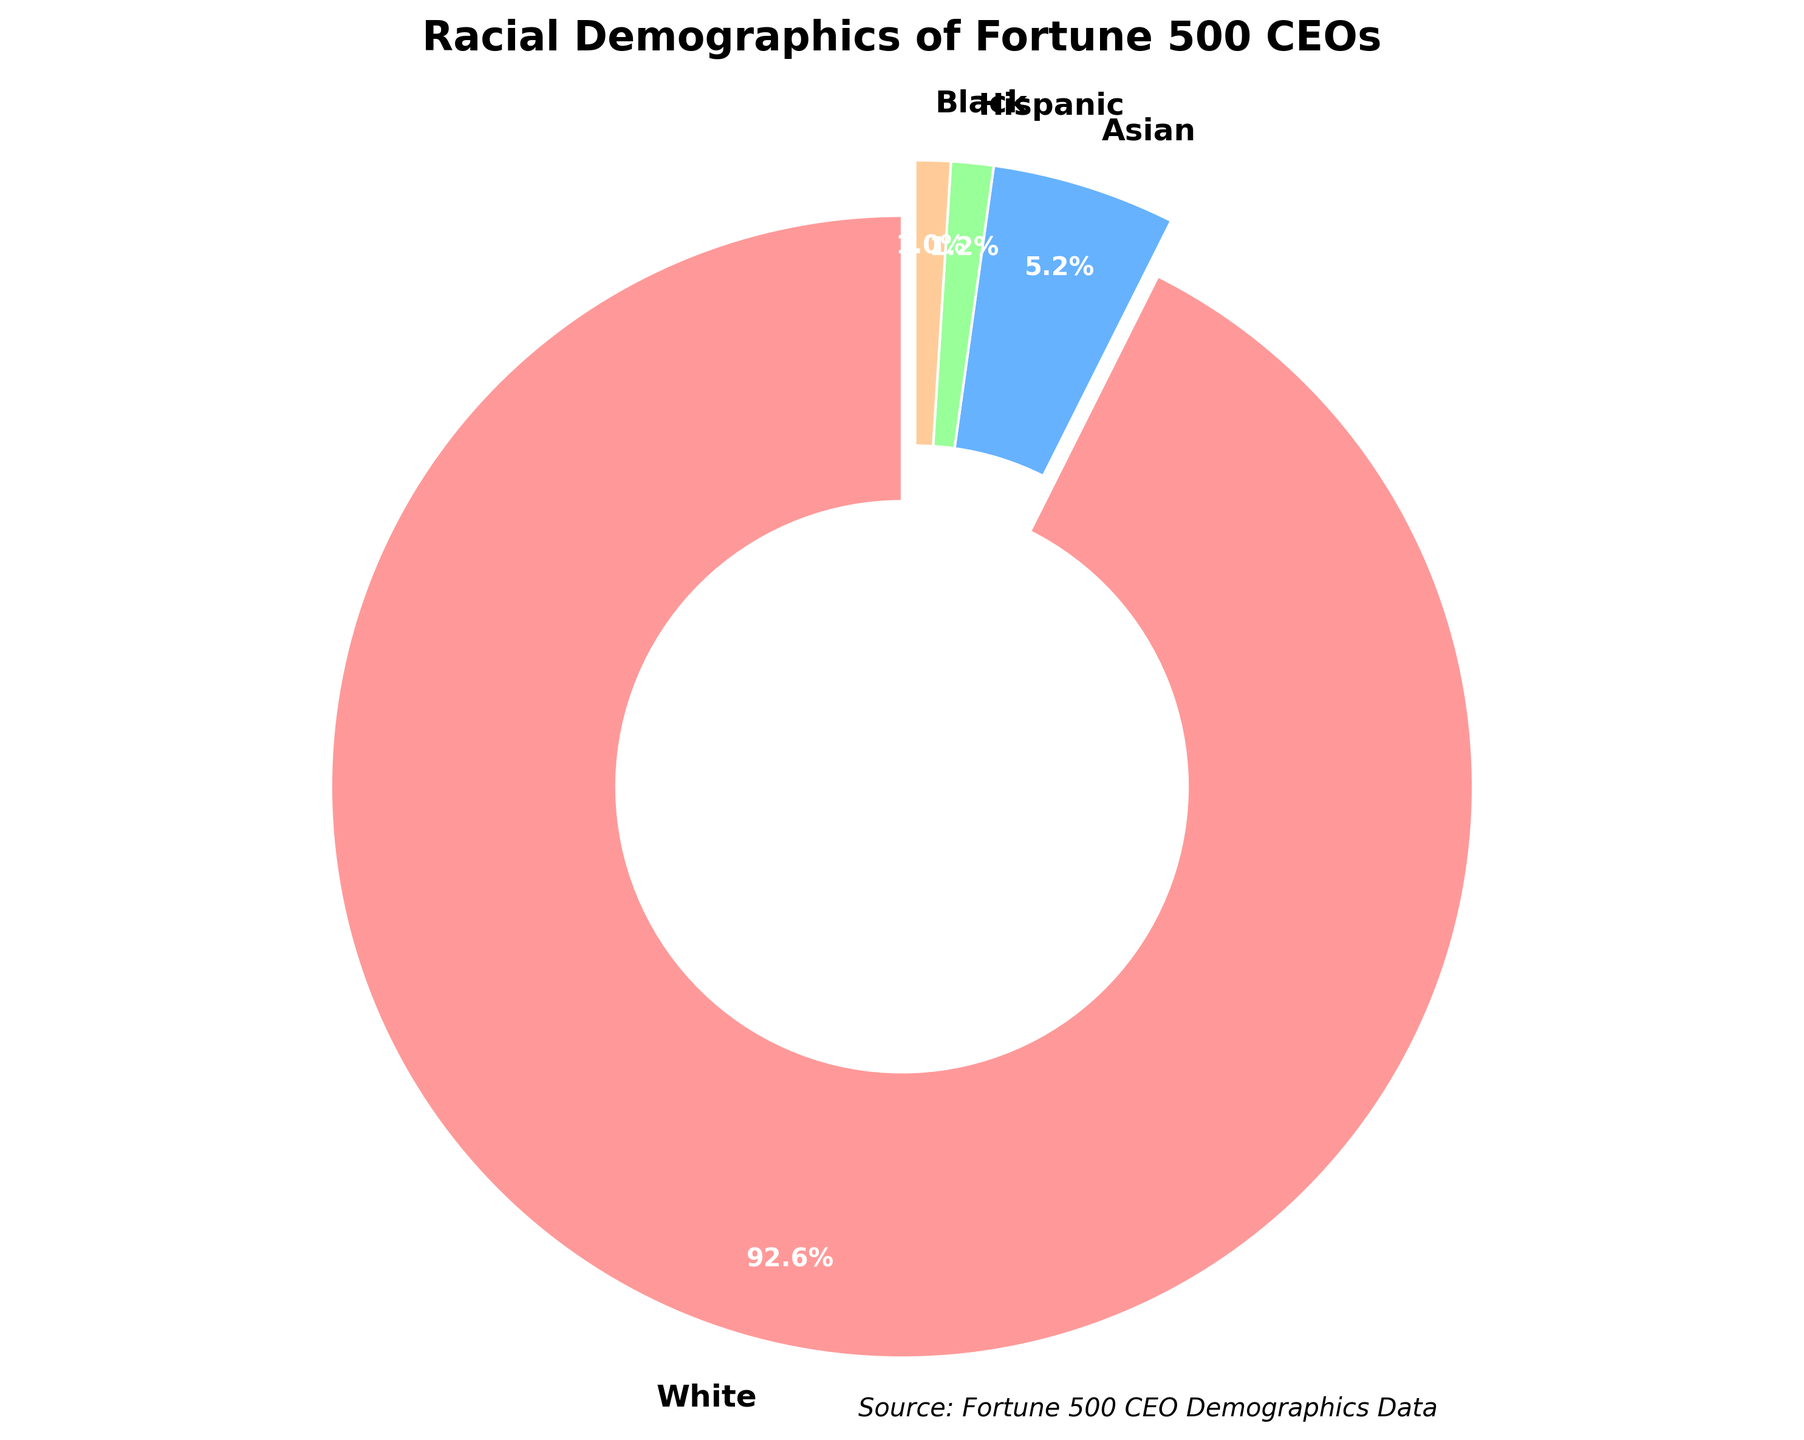What is the percentage representation of Hispanic Fortune 500 CEOs? The pie chart explicitly labels the percentage representation for each race. The Hispanic representation is labeled within the chart.
Answer: 1.2% Which racial group has the highest representation among Fortune 500 CEOs? By visually inspecting the chart, we can see that the largest portion is for the "White" category, which makes up 92.6% of the total.
Answer: White How much greater is the White representation compared to the Asian representation among Fortune 500 CEOs? The percentage for White CEOs is 92.6%, and for Asian CEOs, it is 5.2%. Subtracting the Asian percentage from the White percentage gives 92.6% - 5.2%.
Answer: 87.4% What is the combined percentage of Hispanic and Black Fortune 500 CEOs? The chart lists Hispanic CEOs at 1.2% and Black CEOs at 1.0%. Adding these values together gives 1.2% + 1.0%.
Answer: 2.2% What color represents the smallest demographic of Fortune 500 CEOs according to the pie chart? The smallest demographic is the Black CEOs, represented by 1.0%. By inspecting the pie chart, the corresponding slice color can be identified.
Answer: An identifiable visual answer based on the pie chart If the percentage representation of Asian and Hispanic Fortune 500 CEOs were combined, how would it compare to the percentage of Black Fortune 500 CEOs? The percentages for Asian and Hispanic CEOs are 5.2% and 1.2% respectively. Their combined representation would be 5.2% + 1.2% = 6.4%. The percentage for Black CEOs is 1.0%, so 6.4% is greater than 1.0%.
Answer: Higher What is the difference between the group with the second largest representation and the group with the second smallest representation among Fortune 500 CEOs? The second largest group is Asian with 5.2%, and the second smallest group is Hispanic with 1.2%. The difference is calculated as 5.2% - 1.2%.
Answer: 4.0% How do the representations of Black and Hispanic CEOs compare visually in the pie chart? Visually, both Black and Hispanic groups occupy small slices of the pie chart. The Black CEO representation is slightly smaller at 1.0% compared to Hispanic at 1.2%.
Answer: Hispanic is slightly larger What specific percentage value does the largest wedge in the pie chart represent? The largest wedge in the pie chart represents the White demographic, which is labeled at 92.6%.
Answer: 92.6% 